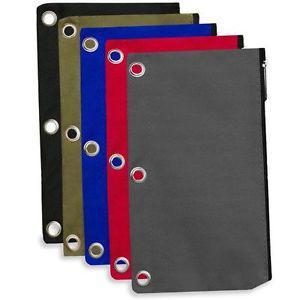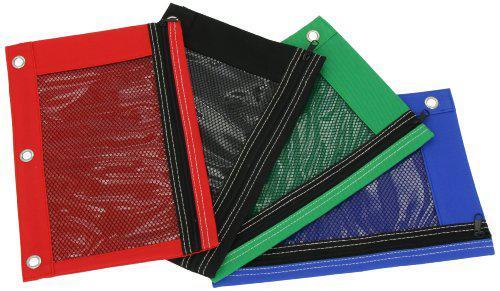The first image is the image on the left, the second image is the image on the right. Evaluate the accuracy of this statement regarding the images: "There are three pencil cases in the right image.". Is it true? Answer yes or no. No. 